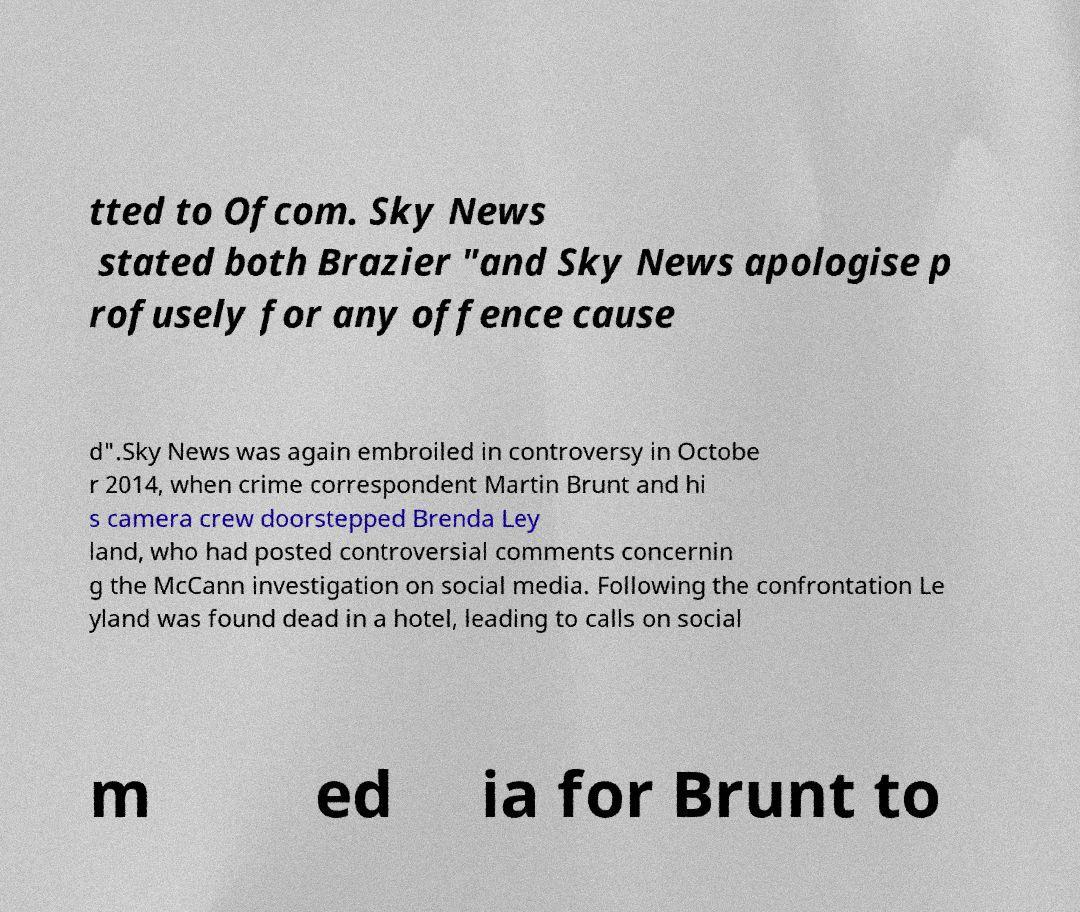Can you read and provide the text displayed in the image?This photo seems to have some interesting text. Can you extract and type it out for me? tted to Ofcom. Sky News stated both Brazier "and Sky News apologise p rofusely for any offence cause d".Sky News was again embroiled in controversy in Octobe r 2014, when crime correspondent Martin Brunt and hi s camera crew doorstepped Brenda Ley land, who had posted controversial comments concernin g the McCann investigation on social media. Following the confrontation Le yland was found dead in a hotel, leading to calls on social m ed ia for Brunt to 